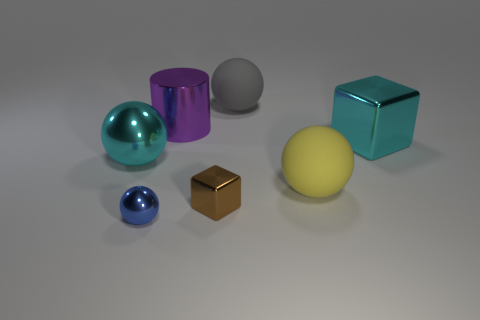Subtract 1 balls. How many balls are left? 3 Add 1 tiny blue metallic objects. How many objects exist? 8 Subtract all cylinders. How many objects are left? 6 Subtract all big rubber things. Subtract all small balls. How many objects are left? 4 Add 3 small blocks. How many small blocks are left? 4 Add 2 tiny blue objects. How many tiny blue objects exist? 3 Subtract 0 red cylinders. How many objects are left? 7 